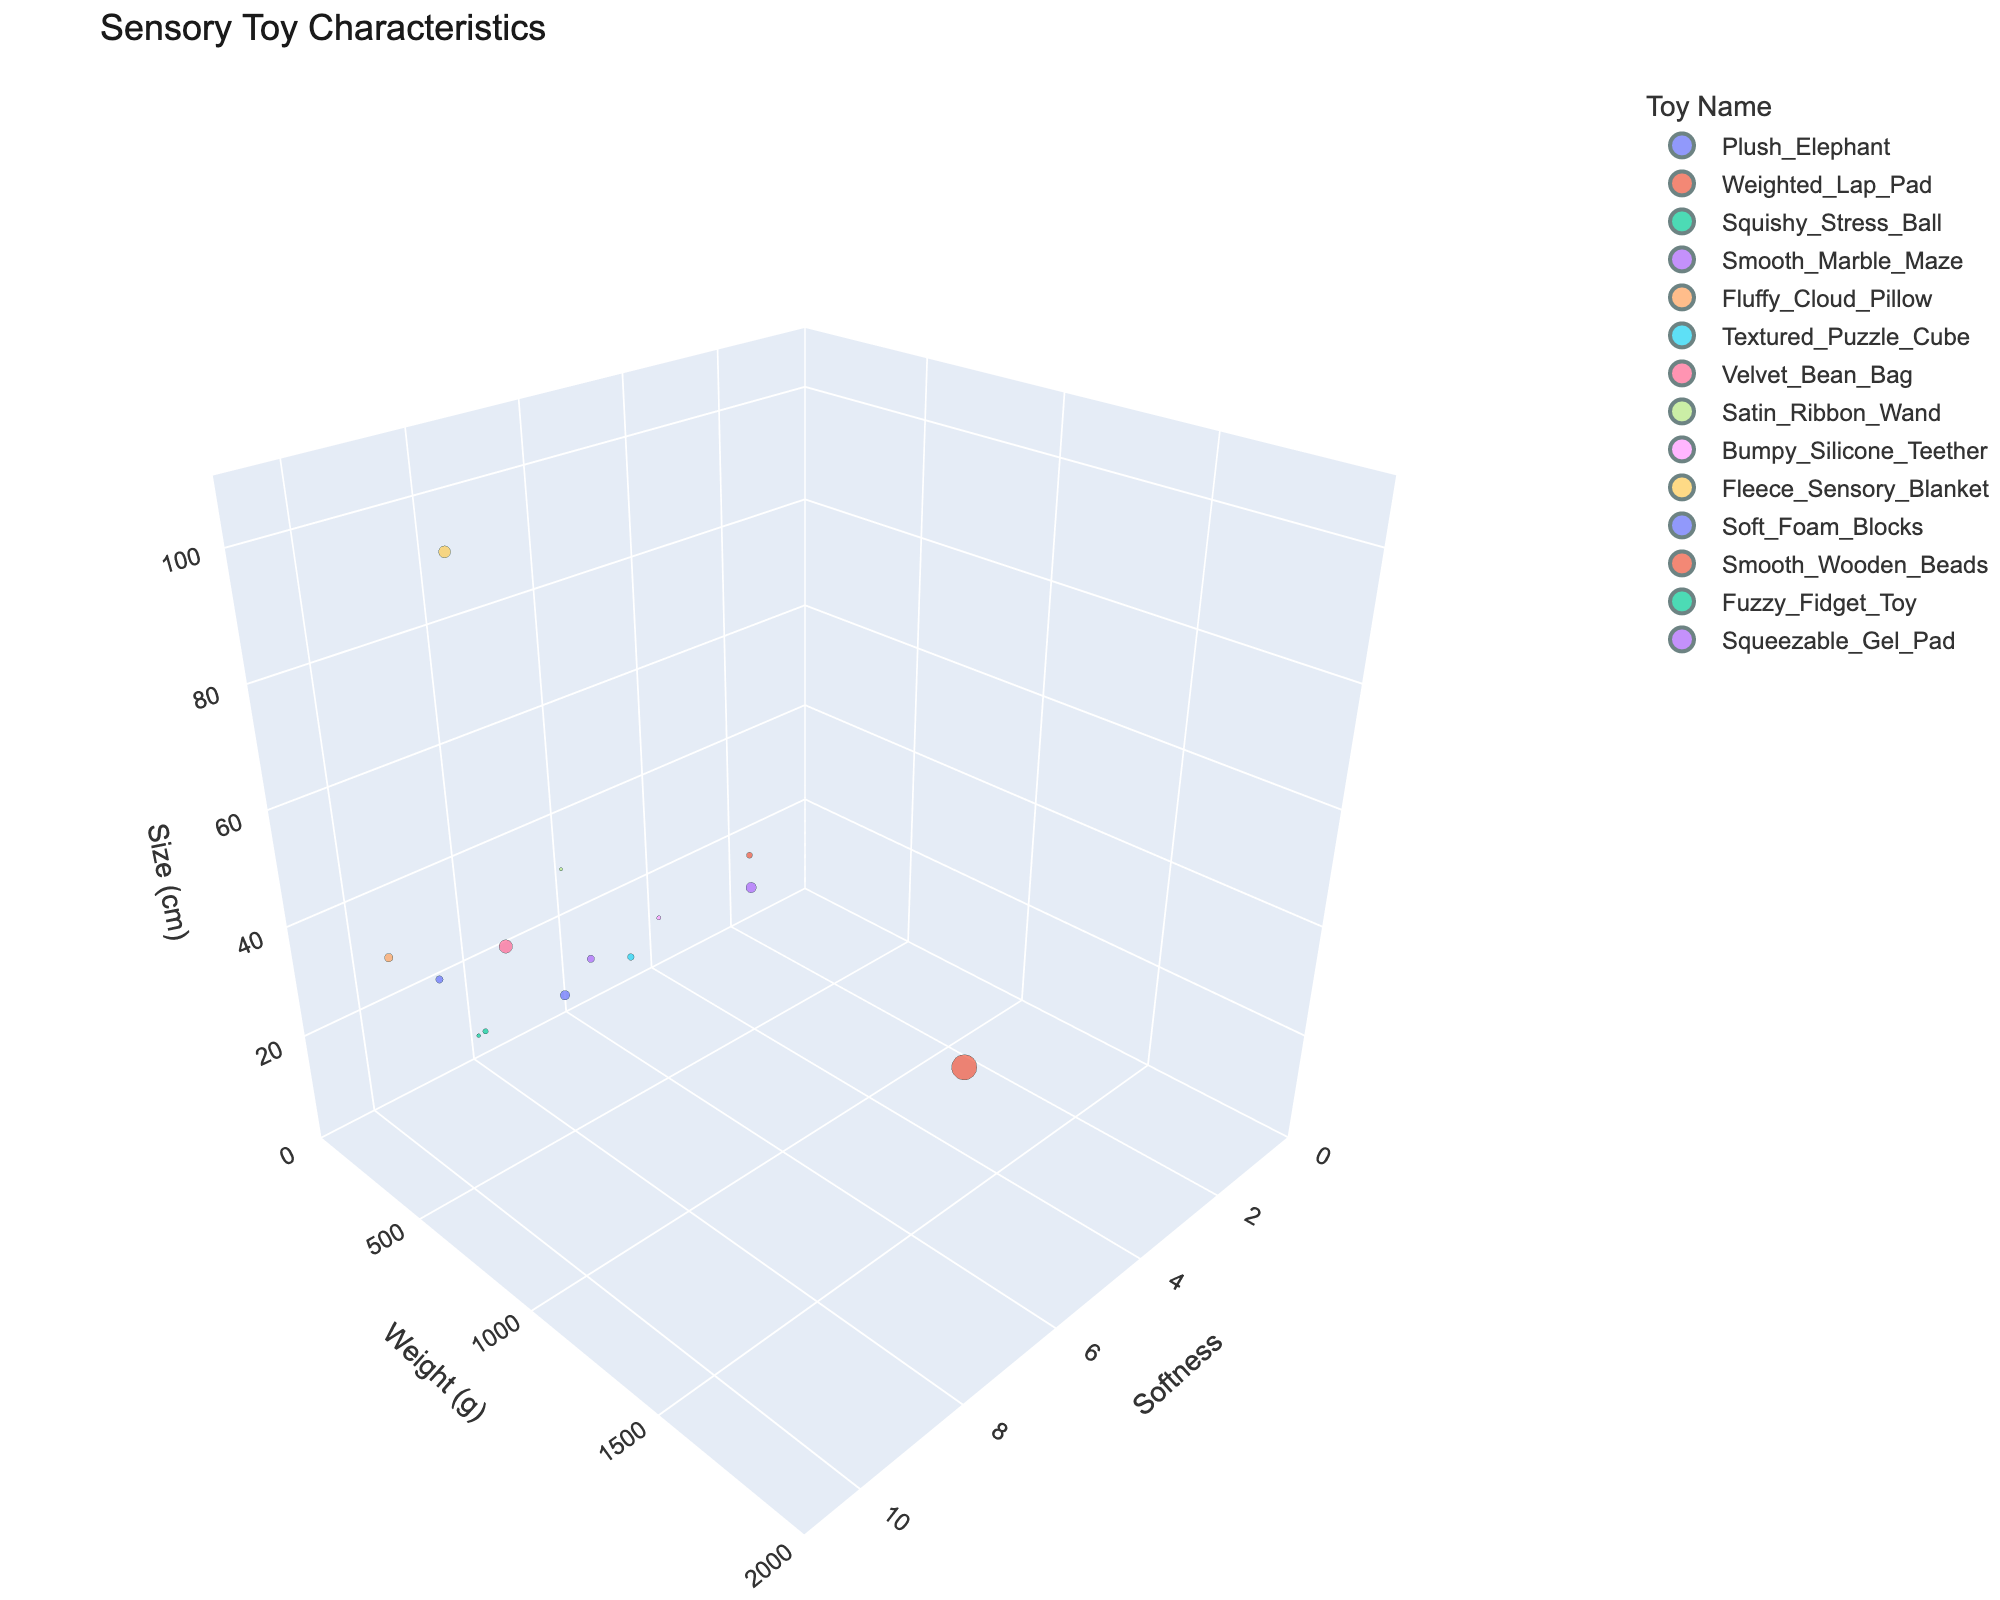what is the softest toy featured in the plot? Look for the toy with the highest value on the softness axis, which is labeled 'Texture_Softness'. The Fluffy_Cloud_Pillow has the highest softness value of 10.
Answer: Fluffy_Cloud_Pillow Which toy has the heaviest weight? Identify the toy with the highest value on the weight axis, which is labeled 'Weight (g)'. The Weighted_Lap_Pad has the highest weight of 1800 grams.
Answer: Weighted_Lap_Pad What is the average softness of the toys with weights greater than 400 grams? First, find toys with weights greater than 400 grams: Weighted_Lap_Pad (1800g), Velvet_Bean_Bag (500g), and Fleece_Sensory_Blanket (400g). Their softness values are 7, 9, and 9. The average is (7+9+9)/3 = 25/3, which is approximately 8.33.
Answer: 8.33 Which toy is the largest by size, and is it also one of the softest? The largest toy has the highest value on the size axis. The Fleece_Sensory_Blanket is 100 cm. Its softness value is 9, which is one of the highest.
Answer: Yes What is the range of sizes for toys with softness values between 6 and 8? Identify toys with softness values between 6 and 8: Weighted_Lap_Pad (45 cm), Squishy_Stress_Ball (8 cm), Satin_Ribbon_Wand (30 cm), Soft_Foam_Blocks (15 cm), Squeezable_Gel_Pad (15 cm). The sizes range from 8 to 45 cm.
Answer: 8 to 45 cm Of the toys with a small size (less than 15 cm), which one weighs the most? Identify toys smaller than 15 cm: Squishy_Stress_Ball (8 cm, 80 g), Textured_Puzzle_Cube (10 cm, 120 g), Bumpy_Silicone_Teether (12 cm, 50 g), Fuzzy_Fidget_Toy (6 cm, 40 g), Soft_Foam_Blocks (15 cm, 250 g), Squeezable_Gel_Pad (15 cm, 150 g). The Soft_Foam_Blocks (250 g) have the highest weight among them.
Answer: Soft_Foam_Blocks 